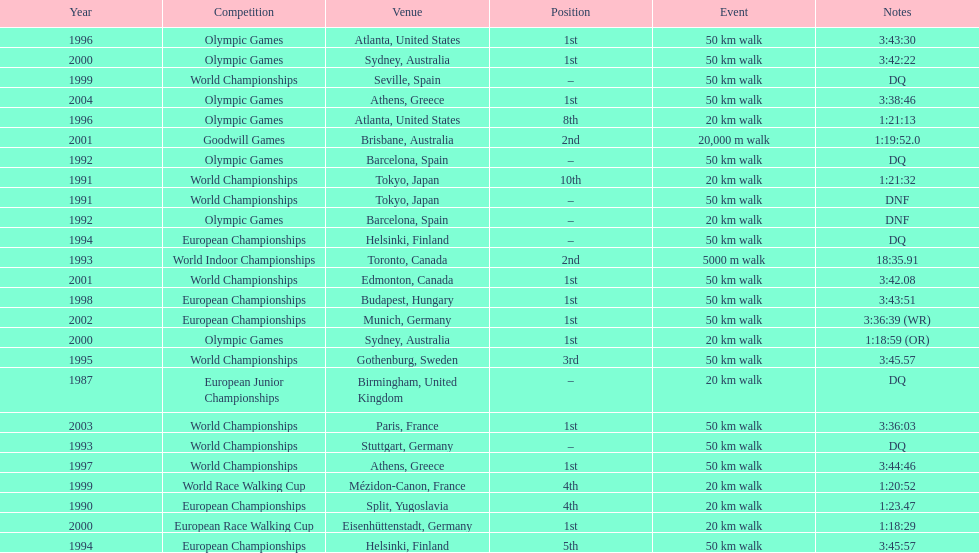What was the name of the competition that took place before the olympic games in 1996? World Championships. 